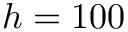Convert formula to latex. <formula><loc_0><loc_0><loc_500><loc_500>h = 1 0 0</formula> 